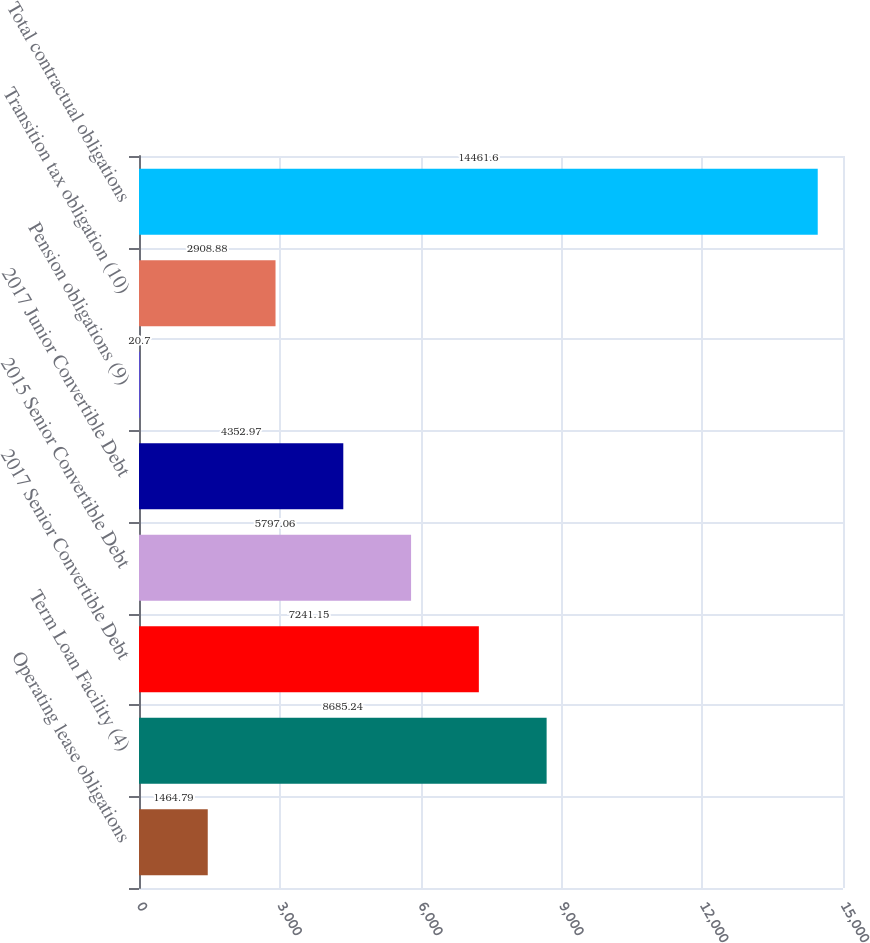Convert chart to OTSL. <chart><loc_0><loc_0><loc_500><loc_500><bar_chart><fcel>Operating lease obligations<fcel>Term Loan Facility (4)<fcel>2017 Senior Convertible Debt<fcel>2015 Senior Convertible Debt<fcel>2017 Junior Convertible Debt<fcel>Pension obligations (9)<fcel>Transition tax obligation (10)<fcel>Total contractual obligations<nl><fcel>1464.79<fcel>8685.24<fcel>7241.15<fcel>5797.06<fcel>4352.97<fcel>20.7<fcel>2908.88<fcel>14461.6<nl></chart> 